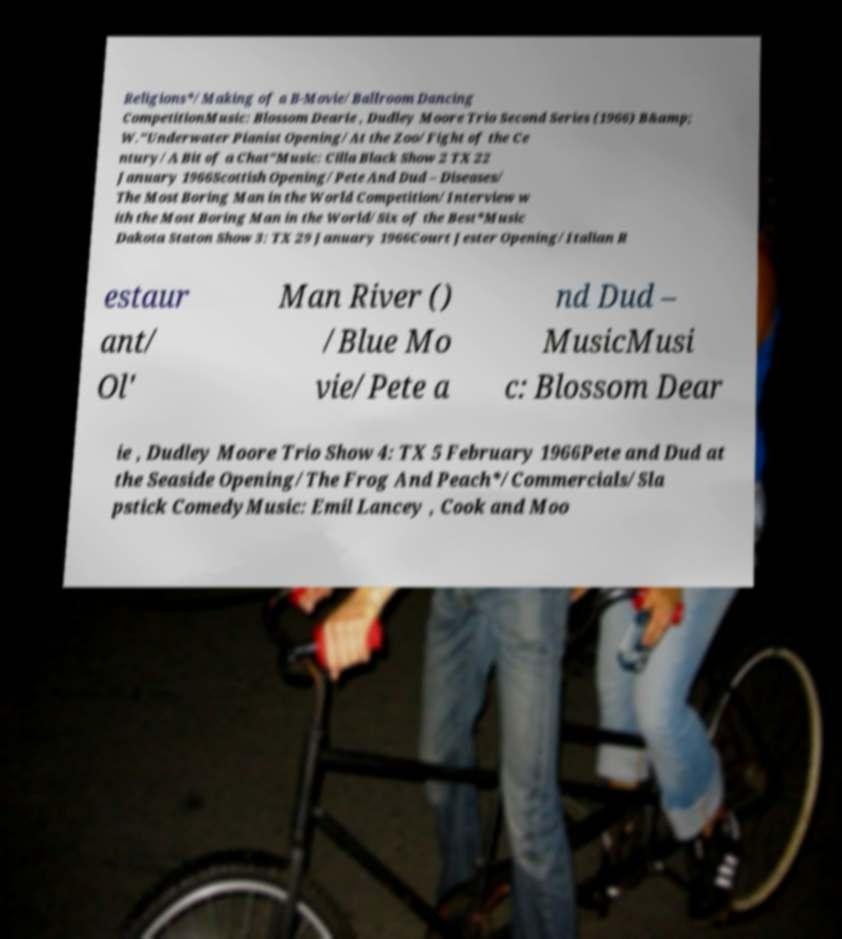There's text embedded in this image that I need extracted. Can you transcribe it verbatim? Religions*/Making of a B-Movie/Ballroom Dancing CompetitionMusic: Blossom Dearie , Dudley Moore Trio Second Series (1966) B&amp; W."Underwater Pianist Opening/At the Zoo/Fight of the Ce ntury/A Bit of a Chat"Music: Cilla Black Show 2 TX 22 January 1966Scottish Opening/Pete And Dud – Diseases/ The Most Boring Man in the World Competition/Interview w ith the Most Boring Man in the World/Six of the Best*Music Dakota Staton Show 3: TX 29 January 1966Court Jester Opening/Italian R estaur ant/ Ol' Man River () /Blue Mo vie/Pete a nd Dud – MusicMusi c: Blossom Dear ie , Dudley Moore Trio Show 4: TX 5 February 1966Pete and Dud at the Seaside Opening/The Frog And Peach*/Commercials/Sla pstick ComedyMusic: Emil Lancey , Cook and Moo 